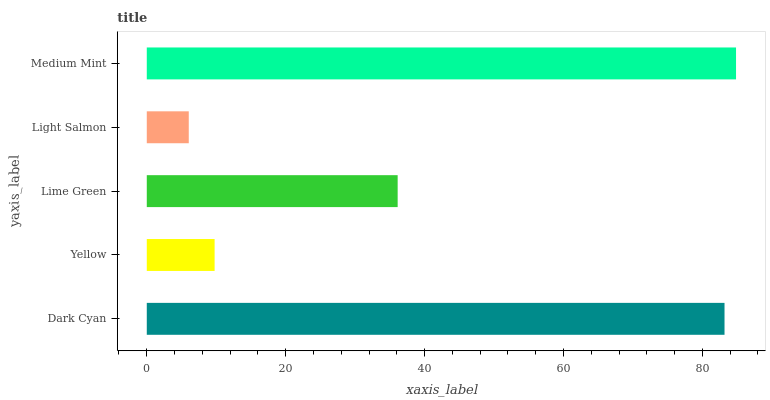Is Light Salmon the minimum?
Answer yes or no. Yes. Is Medium Mint the maximum?
Answer yes or no. Yes. Is Yellow the minimum?
Answer yes or no. No. Is Yellow the maximum?
Answer yes or no. No. Is Dark Cyan greater than Yellow?
Answer yes or no. Yes. Is Yellow less than Dark Cyan?
Answer yes or no. Yes. Is Yellow greater than Dark Cyan?
Answer yes or no. No. Is Dark Cyan less than Yellow?
Answer yes or no. No. Is Lime Green the high median?
Answer yes or no. Yes. Is Lime Green the low median?
Answer yes or no. Yes. Is Yellow the high median?
Answer yes or no. No. Is Yellow the low median?
Answer yes or no. No. 